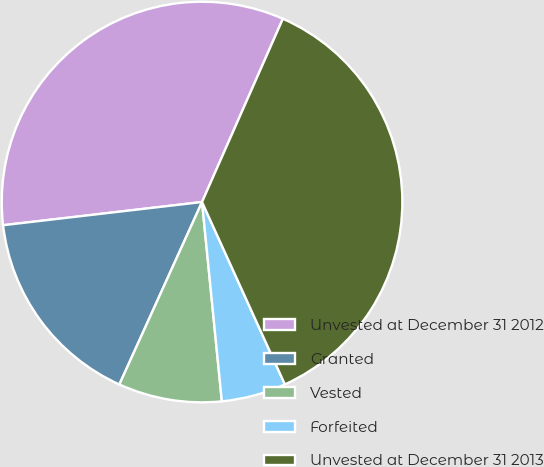Convert chart. <chart><loc_0><loc_0><loc_500><loc_500><pie_chart><fcel>Unvested at December 31 2012<fcel>Granted<fcel>Vested<fcel>Forfeited<fcel>Unvested at December 31 2013<nl><fcel>33.46%<fcel>16.38%<fcel>8.35%<fcel>5.21%<fcel>36.6%<nl></chart> 